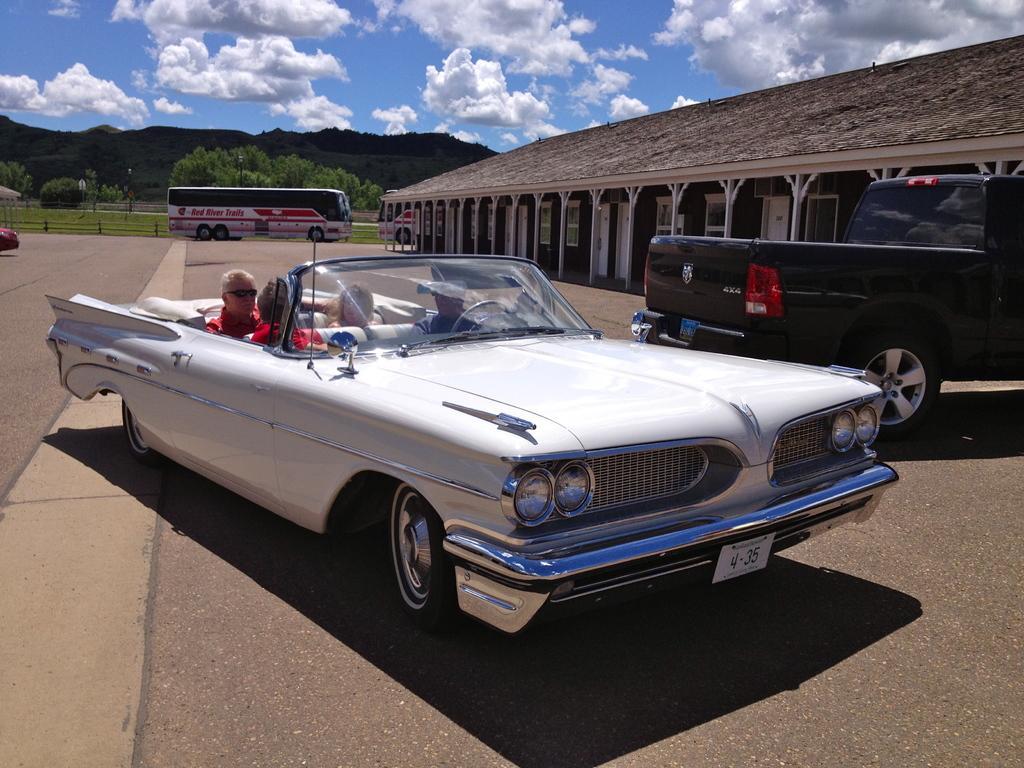In one or two sentences, can you explain what this image depicts? In this image we can see few persons are sitting in a vehicle on the road. In the background we can see vehicles, open shed on the right side, trees, objects and clouds in the sky. 